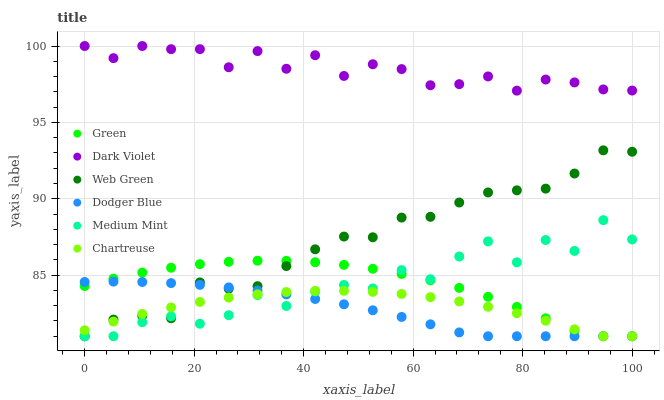Does Dodger Blue have the minimum area under the curve?
Answer yes or no. Yes. Does Dark Violet have the maximum area under the curve?
Answer yes or no. Yes. Does Web Green have the minimum area under the curve?
Answer yes or no. No. Does Web Green have the maximum area under the curve?
Answer yes or no. No. Is Dodger Blue the smoothest?
Answer yes or no. Yes. Is Medium Mint the roughest?
Answer yes or no. Yes. Is Web Green the smoothest?
Answer yes or no. No. Is Web Green the roughest?
Answer yes or no. No. Does Medium Mint have the lowest value?
Answer yes or no. Yes. Does Dark Violet have the lowest value?
Answer yes or no. No. Does Dark Violet have the highest value?
Answer yes or no. Yes. Does Web Green have the highest value?
Answer yes or no. No. Is Dodger Blue less than Dark Violet?
Answer yes or no. Yes. Is Dark Violet greater than Medium Mint?
Answer yes or no. Yes. Does Chartreuse intersect Web Green?
Answer yes or no. Yes. Is Chartreuse less than Web Green?
Answer yes or no. No. Is Chartreuse greater than Web Green?
Answer yes or no. No. Does Dodger Blue intersect Dark Violet?
Answer yes or no. No. 